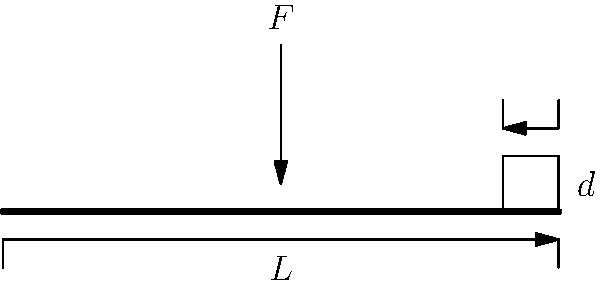Jose Pasillas, the drummer of Incubus, is known for his intense playing style. Consider a drumstick of length $L$ and diameter $d$ at the grip end. If an impact force $F$ is applied at the center of the drumstick during a powerful hit, determine the maximum normal stress $\sigma_{max}$ experienced by the drumstick. Assume the drumstick is made of hickory wood with a Young's modulus $E = 12.6$ GPa. To solve this problem, we'll follow these steps:

1) The drumstick can be modeled as a simply supported beam with a point load at the center.

2) The maximum bending moment $M_{max}$ occurs at the center of the beam and is given by:
   $$M_{max} = \frac{FL}{4}$$

3) The moment of inertia $I$ for a circular cross-section is:
   $$I = \frac{\pi d^4}{64}$$

4) The maximum normal stress $\sigma_{max}$ due to bending is given by:
   $$\sigma_{max} = \frac{M_{max}y}{I}$$
   where $y$ is the distance from the neutral axis to the outer fiber, which is $d/2$ for a circular cross-section.

5) Substituting the expressions for $M_{max}$ and $I$, and $y = d/2$, we get:
   $$\sigma_{max} = \frac{\frac{FL}{4} \cdot \frac{d}{2}}{\frac{\pi d^4}{64}} = \frac{8FL}{\pi d^3}$$

6) This equation gives us the maximum normal stress in terms of the force $F$, length $L$, and diameter $d$.

Note: The Young's modulus $E$ is not directly used in this calculation, but it would be relevant if we needed to calculate the deflection of the drumstick.
Answer: $\sigma_{max} = \frac{8FL}{\pi d^3}$ 